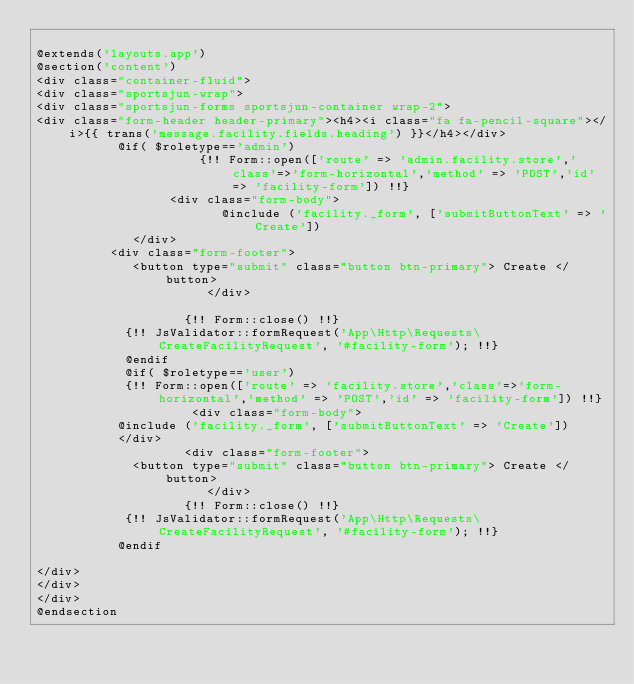<code> <loc_0><loc_0><loc_500><loc_500><_PHP_>
@extends('layouts.app')
@section('content')
<div class="container-fluid">
<div class="sportsjun-wrap">
<div class="sportsjun-forms sportsjun-container wrap-2">
<div class="form-header header-primary"><h4><i class="fa fa-pencil-square"></i>{{ trans('message.facility.fields.heading') }}</h4></div>
					 @if( $roletype=='admin')
                      {!! Form::open(['route' => 'admin.facility.store','class'=>'form-horizontal','method' => 'POST','id' => 'facility-form']) !!} 
	                <div class="form-body">				  
                         @include ('facility._form', ['submitButtonText' => 'Create'])
						 </div>		
					<div class="form-footer">
						 <button type="submit" class="button btn-primary"> Create </button>		
                       </div>
		
                    {!! Form::close() !!}
					  {!! JsValidator::formRequest('App\Http\Requests\CreateFacilityRequest', '#facility-form'); !!}
			      @endif
			      @if( $roletype=='user')
			      {!! Form::open(['route' => 'facility.store','class'=>'form-horizontal','method' => 'POST','id' => 'facility-form']) !!}   
                     <div class="form-body">			
					 @include ('facility._form', ['submitButtonText' => 'Create'])
					 </div>	
                    <div class="form-footer">
						 <button type="submit" class="button btn-primary"> Create </button>		
                       </div>					 
                    {!! Form::close() !!}
					  {!! JsValidator::formRequest('App\Http\Requests\CreateFacilityRequest', '#facility-form'); !!}
			     @endif
				 
</div>
</div>
</div>
@endsection
</code> 